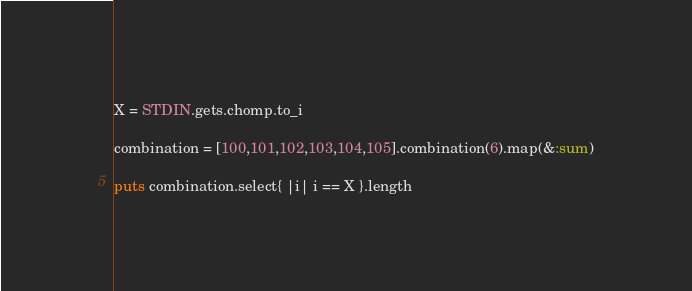Convert code to text. <code><loc_0><loc_0><loc_500><loc_500><_Ruby_>X = STDIN.gets.chomp.to_i

combination = [100,101,102,103,104,105].combination(6).map(&:sum)

puts combination.select{ |i| i == X }.length</code> 